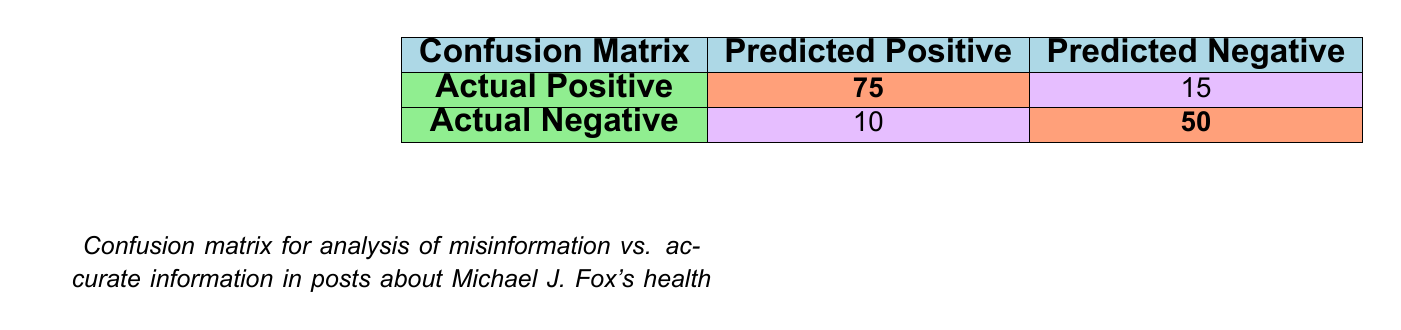What is the value of true positives in the confusion matrix? The table indicates that the number of true positives is represented in the second row, first column. The value is 75.
Answer: 75 What is the number of false negatives? The false negatives can be found in the second row, second column. According to the table, the number is 15.
Answer: 15 How many actual negative posts were predicted as positive? To find this, we look at the first row, second column, which shows the number of false positives. This value is 10.
Answer: 10 What is the total number of accurate information posts? The total number of accurate posts includes both true positives and false negatives. Adding these values together: 75 (true positives) + 15 (false negatives) equals 90.
Answer: 90 Is the number of true negatives greater than the number of false positives? The true negatives are listed as 50, and the false positives are listed as 10. Since 50 is greater than 10, the statement is true.
Answer: Yes What percentage of the actual positives were correctly predicted (true positives)? To calculate the percentage of true positives out of actual positives, use the formula: (true positives / actual positives) * 100%. The actual positives are 75 + 15 = 90, thus (75 / 90) * 100% = 83.33%.
Answer: 83.33% What is the sum of false positives and false negatives? To find this, we simply add the false positives (10) and false negatives (15). Therefore, the sum is 10 + 15 = 25.
Answer: 25 If a post is predicted as negative, what is the probability it is actually negative (true negative rate)? The true negative rate is calculated as true negatives / actual negatives. We know the true negatives are 50, while the actual negatives are 50 (true negatives) + 10 (false positives) = 60. Thus, the calculation is 50 / 60 = 0.8333 or 83.33%.
Answer: 83.33% 